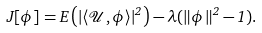<formula> <loc_0><loc_0><loc_500><loc_500>J [ \phi ] = E \left ( | \langle \mathcal { U } , \phi \rangle | ^ { 2 } \right ) - \lambda ( \| \phi \| ^ { 2 } - 1 ) .</formula> 